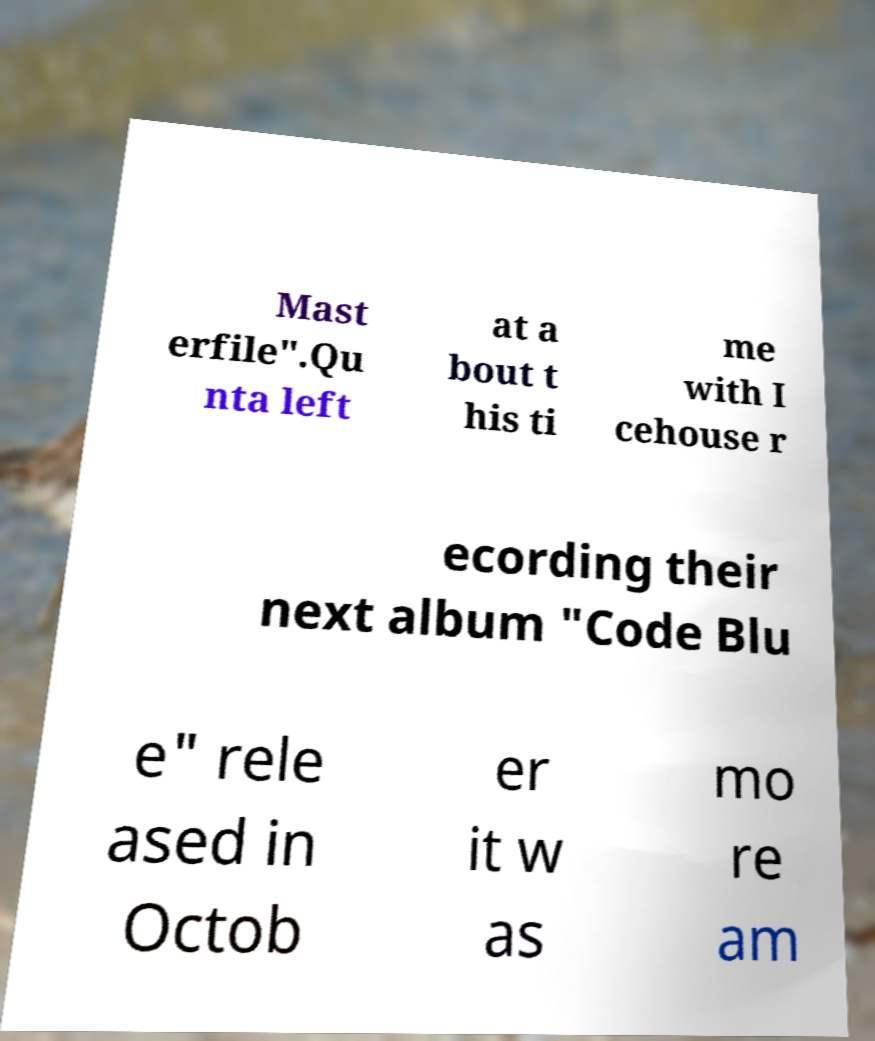Could you extract and type out the text from this image? Mast erfile".Qu nta left at a bout t his ti me with I cehouse r ecording their next album "Code Blu e" rele ased in Octob er it w as mo re am 